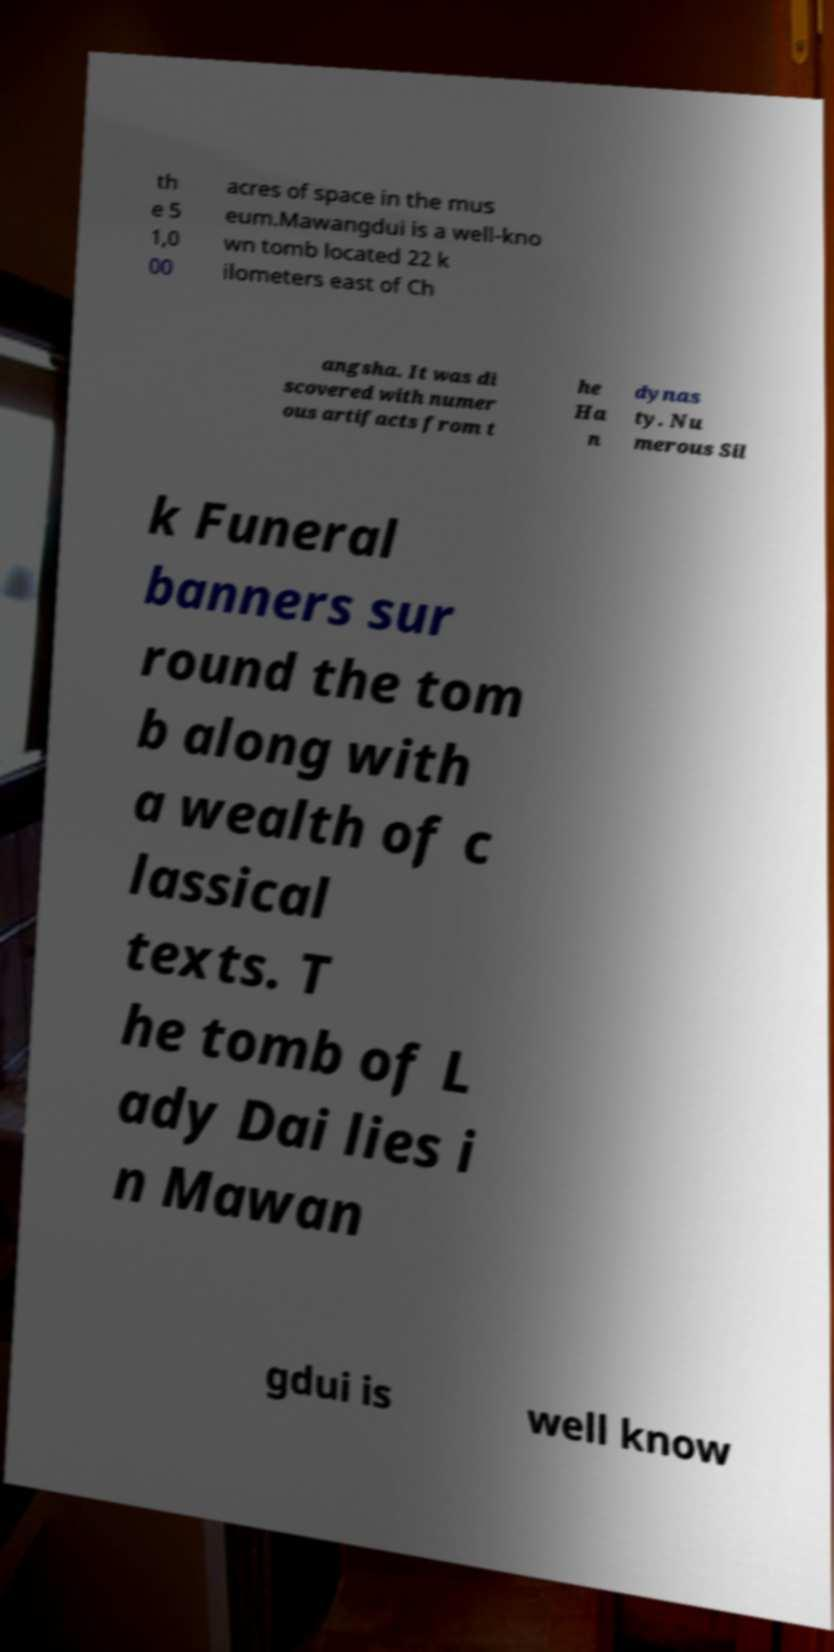Can you read and provide the text displayed in the image?This photo seems to have some interesting text. Can you extract and type it out for me? th e 5 1,0 00 acres of space in the mus eum.Mawangdui is a well-kno wn tomb located 22 k ilometers east of Ch angsha. It was di scovered with numer ous artifacts from t he Ha n dynas ty. Nu merous Sil k Funeral banners sur round the tom b along with a wealth of c lassical texts. T he tomb of L ady Dai lies i n Mawan gdui is well know 